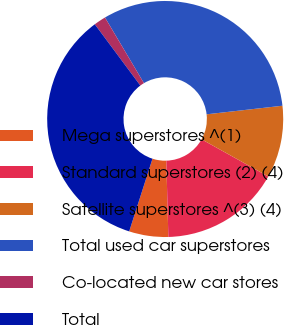Convert chart. <chart><loc_0><loc_0><loc_500><loc_500><pie_chart><fcel>Mega superstores ^(1)<fcel>Standard superstores (2) (4)<fcel>Satellite superstores ^(3) (4)<fcel>Total used car superstores<fcel>Co-located new car stores<fcel>Total<nl><fcel>5.36%<fcel>16.48%<fcel>9.89%<fcel>31.73%<fcel>1.65%<fcel>34.9%<nl></chart> 